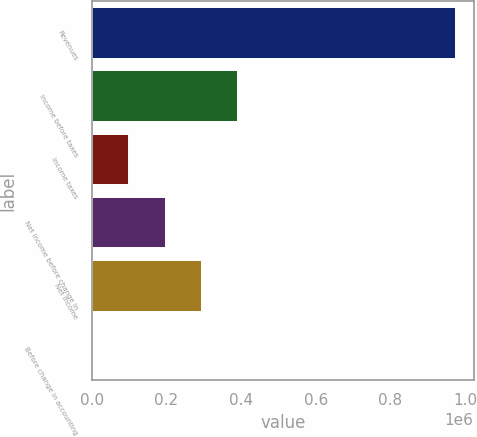Convert chart. <chart><loc_0><loc_0><loc_500><loc_500><bar_chart><fcel>Revenues<fcel>Income before taxes<fcel>Income taxes<fcel>Net income before change in<fcel>Net income<fcel>Before change in accounting<nl><fcel>974520<fcel>389808<fcel>97452.3<fcel>194904<fcel>292356<fcel>0.32<nl></chart> 